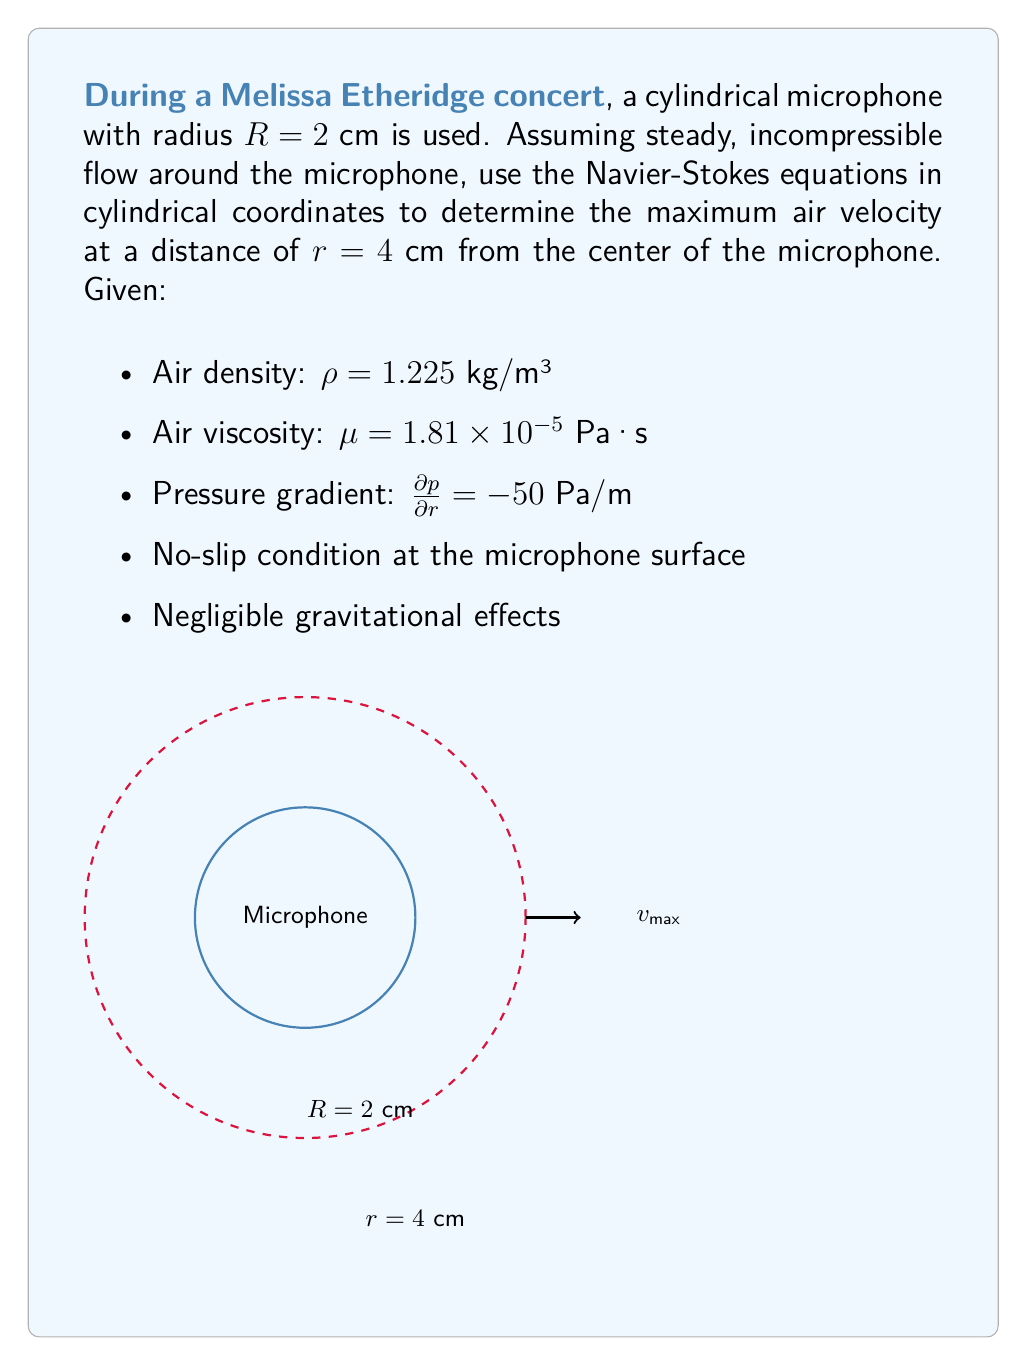Solve this math problem. Let's approach this problem step-by-step using the Navier-Stokes equations in cylindrical coordinates:

1) For steady, incompressible flow with only radial velocity component $v_r$, the Navier-Stokes equation in the radial direction simplifies to:

   $$\rho \left(v_r \frac{\partial v_r}{\partial r}\right) = -\frac{\partial p}{\partial r} + \mu \left(\frac{\partial^2 v_r}{\partial r^2} + \frac{1}{r}\frac{\partial v_r}{\partial r} - \frac{v_r}{r^2}\right)$$

2) For fully developed flow, $\frac{\partial v_r}{\partial r} = 0$, so the equation simplifies to:

   $$0 = -\frac{\partial p}{\partial r} + \mu \left(\frac{\partial^2 v_r}{\partial r^2} - \frac{v_r}{r^2}\right)$$

3) Rearranging:

   $$\frac{\partial^2 v_r}{\partial r^2} - \frac{v_r}{r^2} = \frac{1}{\mu}\frac{\partial p}{\partial r}$$

4) This is a second-order differential equation. The general solution is:

   $$v_r = C_1 r + \frac{C_2}{r} - \frac{r}{4\mu}\frac{\partial p}{\partial r}$$

5) Apply boundary conditions:
   - At $r = R$ (microphone surface), $v_r = 0$ (no-slip condition)
   - As $r \to \infty$, $v_r$ should remain finite

6) The second condition implies $C_1 = 0$. Using the first condition:

   $$0 = \frac{C_2}{R} - \frac{R}{4\mu}\frac{\partial p}{\partial r}$$

   $$C_2 = \frac{R^2}{4\mu}\frac{\partial p}{\partial r}$$

7) Therefore, the velocity profile is:

   $$v_r = \frac{R^2}{4\mu r}\frac{\partial p}{\partial r} - \frac{r}{4\mu}\frac{\partial p}{\partial r}$$

8) To find the maximum velocity at $r = 4$ cm, substitute the given values:

   $$v_r = \frac{(0.02)^2}{4(1.81 \times 10^{-5})(0.04)}(-50) - \frac{0.04}{4(1.81 \times 10^{-5})}(-50)$$

9) Simplify:

   $$v_r = 0.1381 + 0.5525 = 0.6906 \text{ m/s}$$

Thus, the maximum air velocity at $r = 4$ cm is approximately 0.6906 m/s.
Answer: 0.6906 m/s 